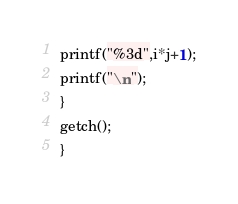<code> <loc_0><loc_0><loc_500><loc_500><_C_>printf("%3d",i*j+1);
printf("\n");
}
getch();
}
</code> 